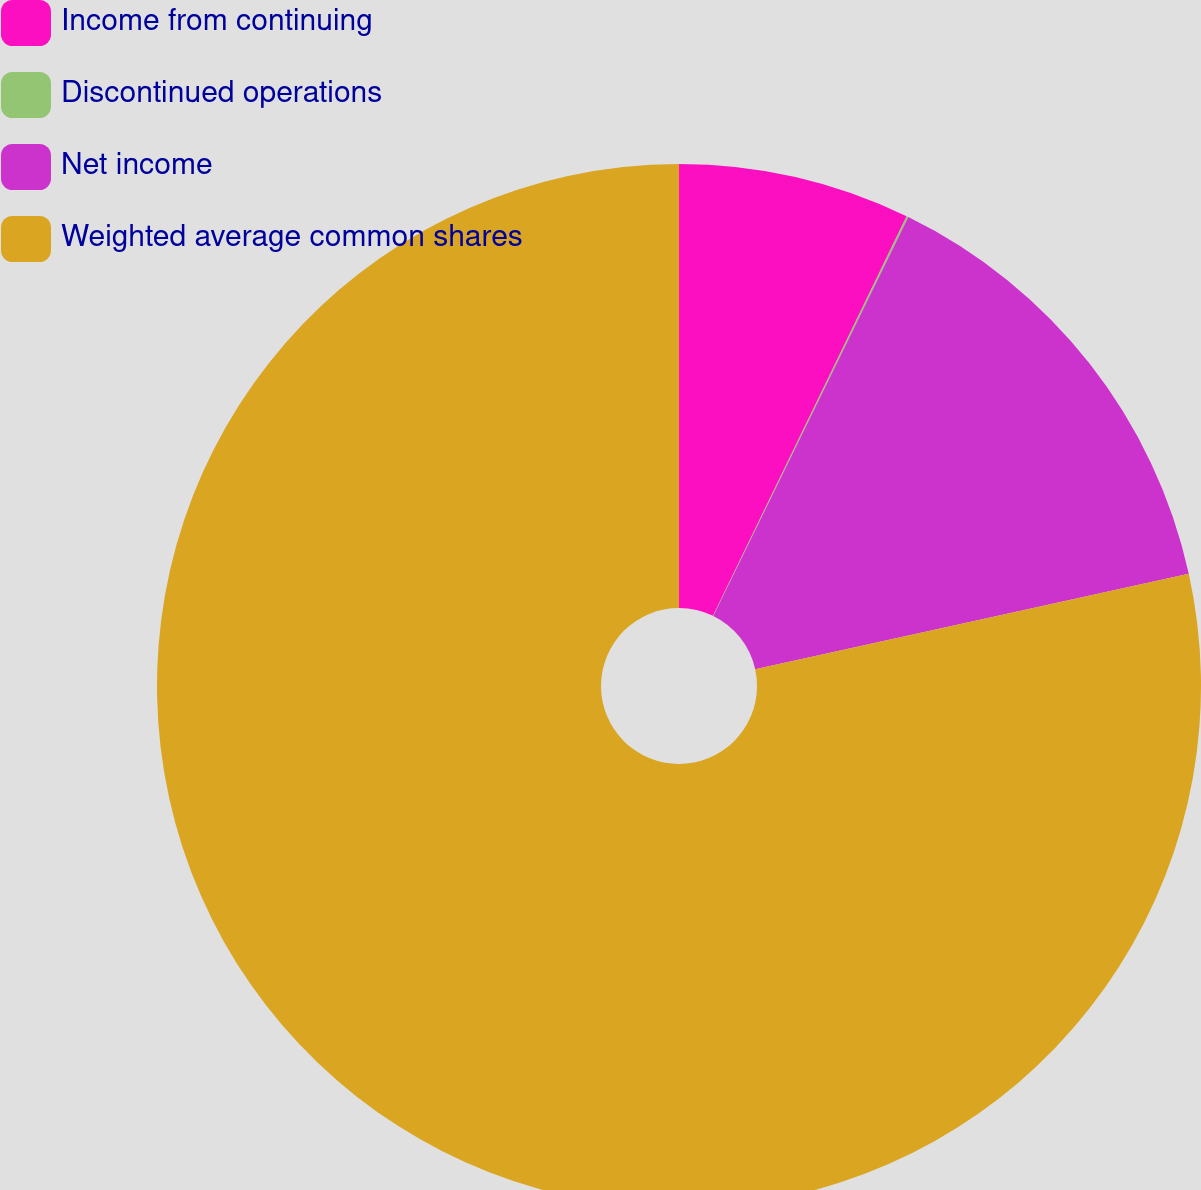Convert chart to OTSL. <chart><loc_0><loc_0><loc_500><loc_500><pie_chart><fcel>Income from continuing<fcel>Discontinued operations<fcel>Net income<fcel>Weighted average common shares<nl><fcel>7.18%<fcel>0.06%<fcel>14.31%<fcel>78.45%<nl></chart> 